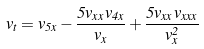<formula> <loc_0><loc_0><loc_500><loc_500>v _ { t } = v _ { 5 x } - \frac { 5 v _ { x x } v _ { 4 x } } { v _ { x } } + \frac { 5 v _ { x x } v _ { x x x } } { v _ { x } ^ { 2 } }</formula> 